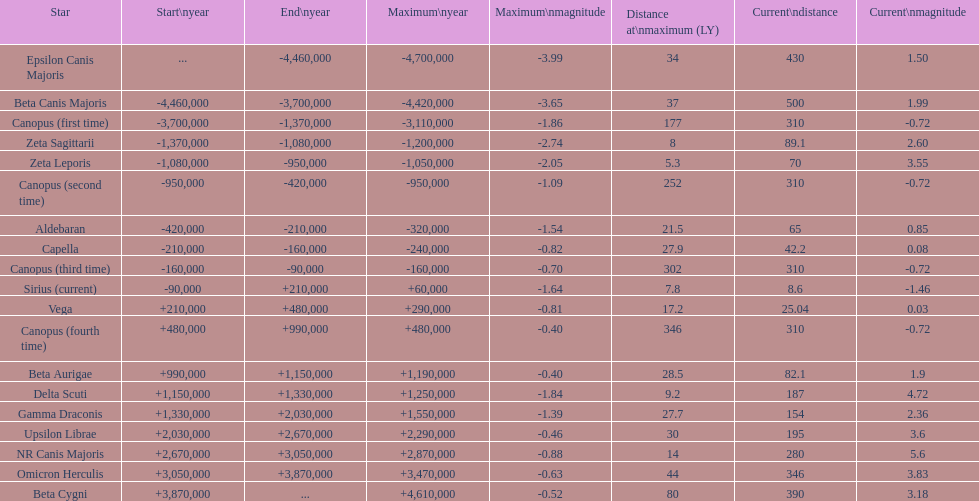What is the difference in the nearest current distance and farthest current distance? 491.4. 